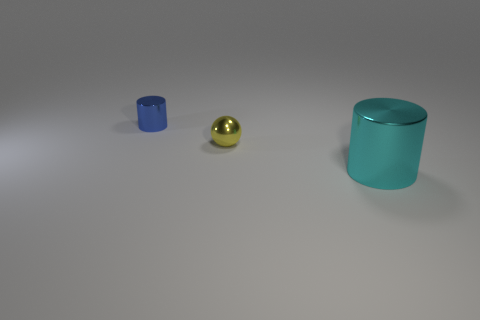Subtract all cyan cylinders. How many cylinders are left? 1 Subtract 1 yellow balls. How many objects are left? 2 Subtract all cylinders. How many objects are left? 1 Subtract 2 cylinders. How many cylinders are left? 0 Subtract all yellow cylinders. Subtract all gray spheres. How many cylinders are left? 2 Subtract all red blocks. How many cyan cylinders are left? 1 Subtract all tiny cylinders. Subtract all red rubber things. How many objects are left? 2 Add 3 balls. How many balls are left? 4 Add 2 small cylinders. How many small cylinders exist? 3 Add 2 yellow spheres. How many objects exist? 5 